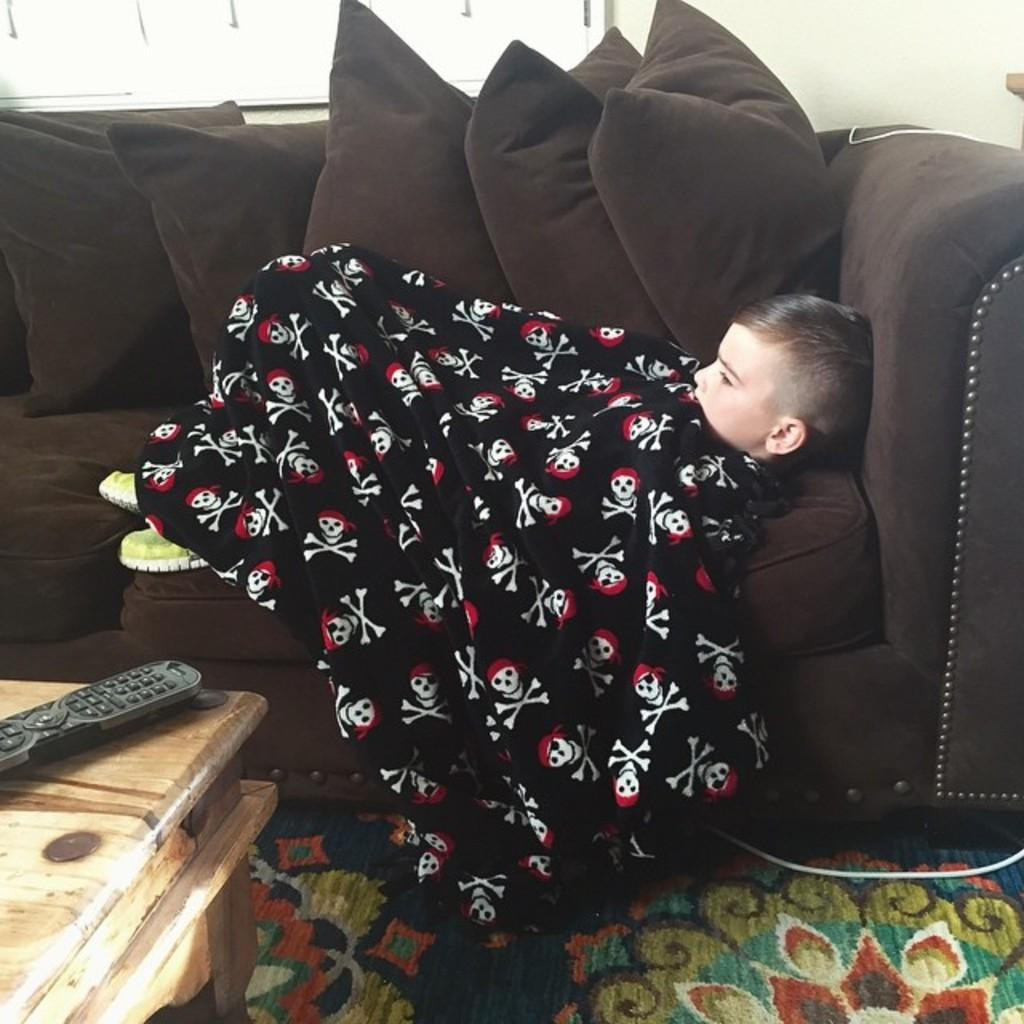What is the kid doing in the image? The kid is sleeping on the sofa. How is the kid positioned on the sofa? The kid is covered with a cloth. What is located beside the sofa? There is a table beside the sofa. What object can be seen on the table? A remote is on the table. Where is the pencil stored in the image? There is no pencil present in the image. What type of cellar can be seen in the image? There is no cellar present in the image. 